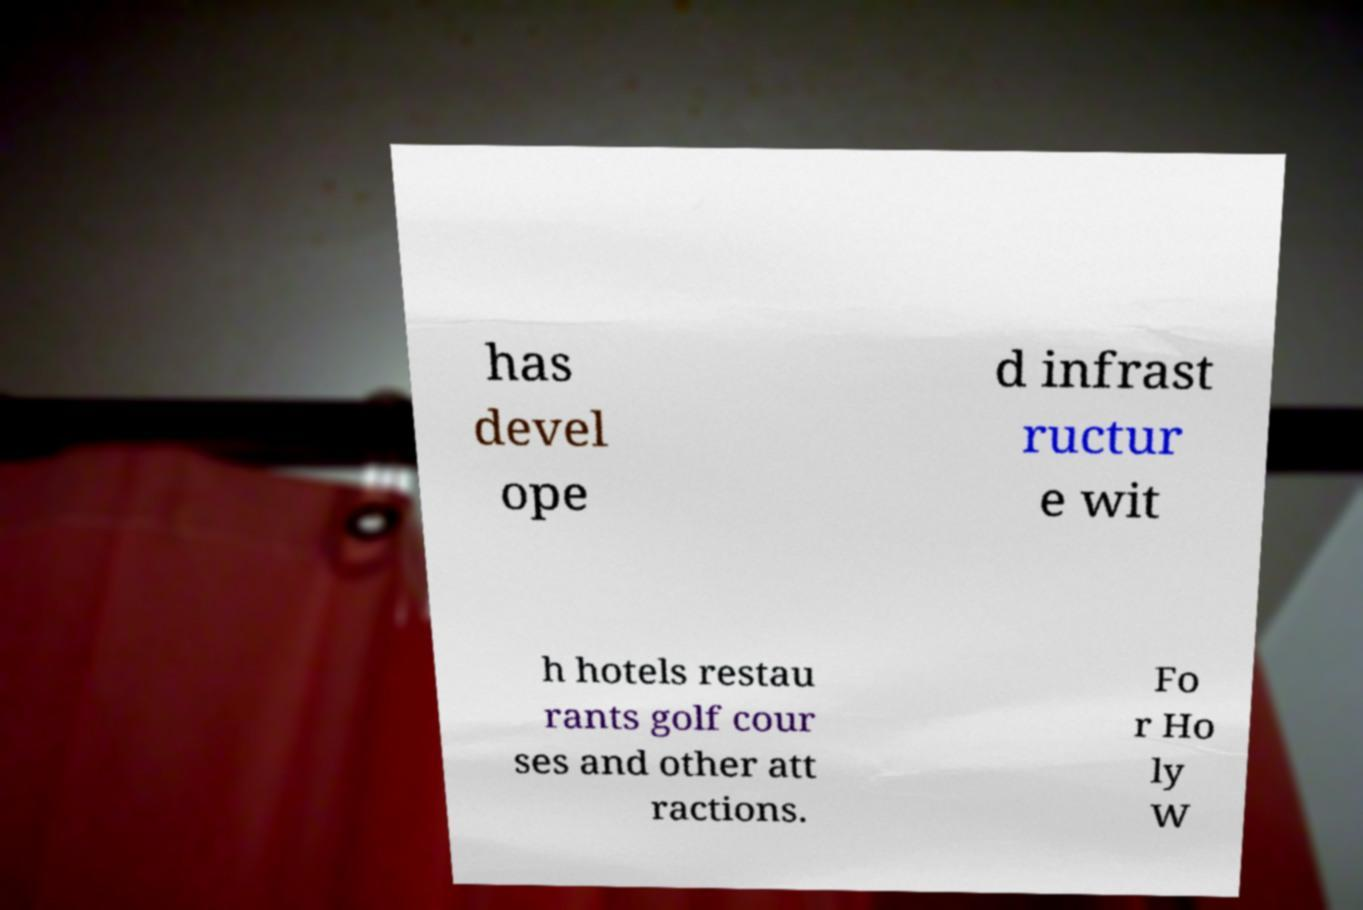I need the written content from this picture converted into text. Can you do that? has devel ope d infrast ructur e wit h hotels restau rants golf cour ses and other att ractions. Fo r Ho ly W 